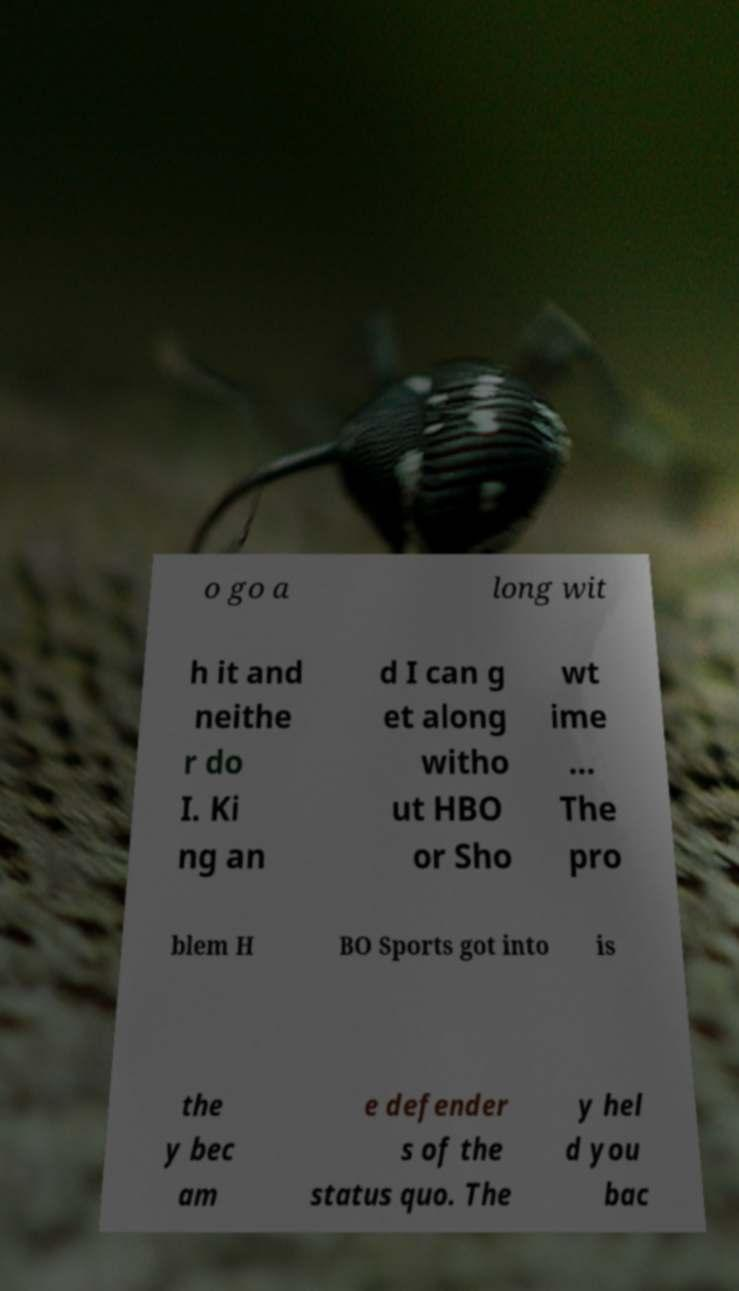What messages or text are displayed in this image? I need them in a readable, typed format. o go a long wit h it and neithe r do I. Ki ng an d I can g et along witho ut HBO or Sho wt ime ... The pro blem H BO Sports got into is the y bec am e defender s of the status quo. The y hel d you bac 